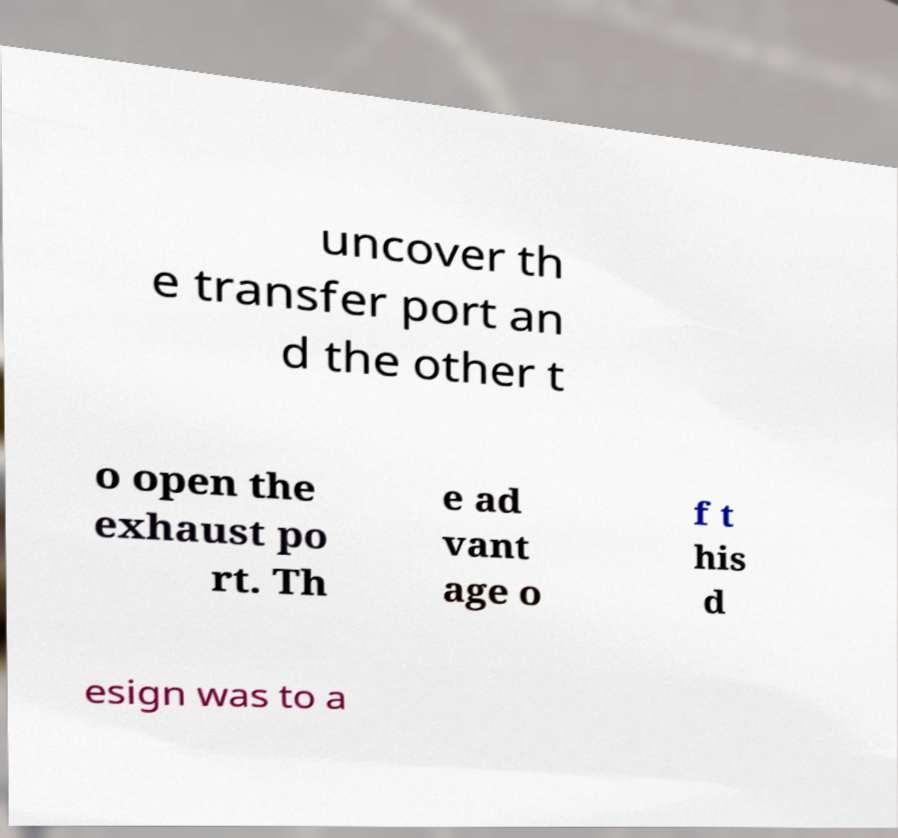What messages or text are displayed in this image? I need them in a readable, typed format. uncover th e transfer port an d the other t o open the exhaust po rt. Th e ad vant age o f t his d esign was to a 